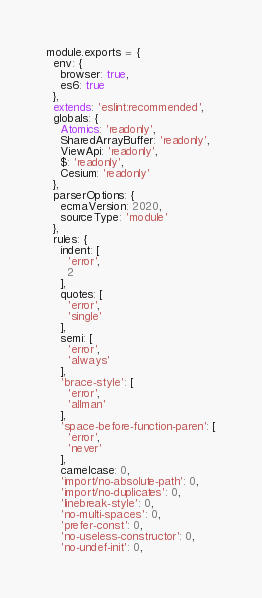<code> <loc_0><loc_0><loc_500><loc_500><_JavaScript_>module.exports = {
  env: {
    browser: true,
    es6: true
  },
  extends: 'eslint:recommended',
  globals: {
    Atomics: 'readonly',
    SharedArrayBuffer: 'readonly',
    ViewApi: 'readonly',
    $: 'readonly',
    Cesium: 'readonly'
  },
  parserOptions: {
    ecmaVersion: 2020,
    sourceType: 'module'
  },
  rules: {
    indent: [
      'error',
      2
    ],
    quotes: [
      'error',
      'single'
    ],
    semi: [
      'error',
      'always'
    ],
    'brace-style': [
      'error',
      'allman'
    ],
    'space-before-function-paren': [
      'error',
      'never'
    ],
    camelcase: 0,
    'import/no-absolute-path': 0,
    'import/no-duplicates': 0,
    'linebreak-style': 0,
    'no-multi-spaces': 0,
    'prefer-const': 0,
    'no-useless-constructor': 0,
    'no-undef-init': 0,</code> 